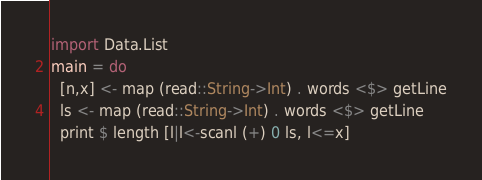<code> <loc_0><loc_0><loc_500><loc_500><_Haskell_>import Data.List
main = do
  [n,x] <- map (read::String->Int) . words <$> getLine
  ls <- map (read::String->Int) . words <$> getLine
  print $ length [l|l<-scanl (+) 0 ls, l<=x]</code> 